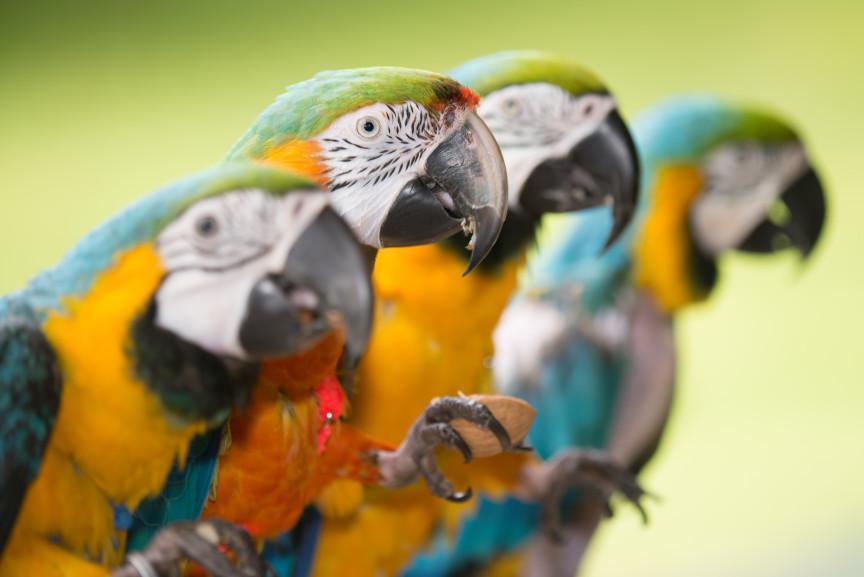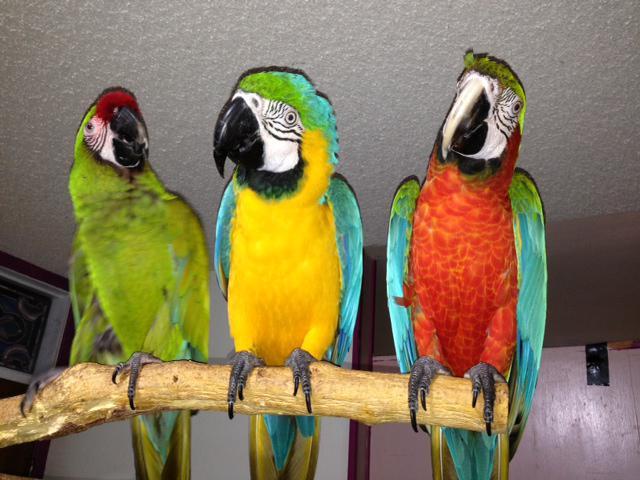The first image is the image on the left, the second image is the image on the right. Given the left and right images, does the statement "There is at least one image where there is a cage." hold true? Answer yes or no. No. The first image is the image on the left, the second image is the image on the right. Examine the images to the left and right. Is the description "In one image there are 3 parrots standing on a branch" accurate? Answer yes or no. Yes. 